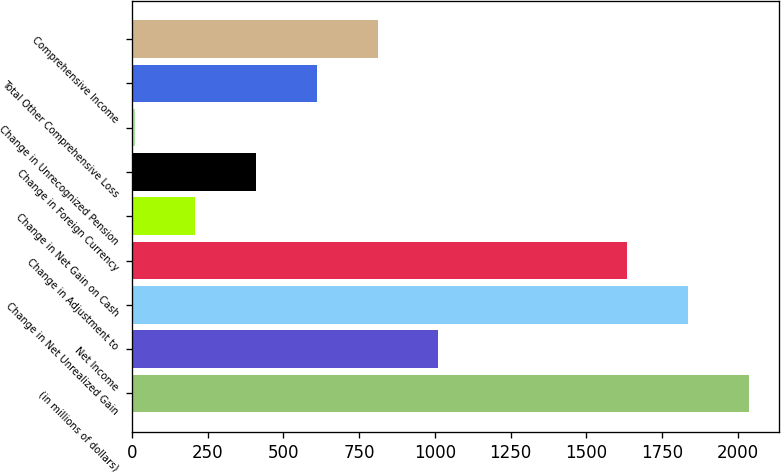<chart> <loc_0><loc_0><loc_500><loc_500><bar_chart><fcel>(in millions of dollars)<fcel>Net Income<fcel>Change in Net Unrealized Gain<fcel>Change in Adjustment to<fcel>Change in Net Gain on Cash<fcel>Change in Foreign Currency<fcel>Change in Unrecognized Pension<fcel>Total Other Comprehensive Loss<fcel>Comprehensive Income<nl><fcel>2036.12<fcel>1011.95<fcel>1835.51<fcel>1634.9<fcel>209.51<fcel>410.12<fcel>8.9<fcel>610.73<fcel>811.34<nl></chart> 